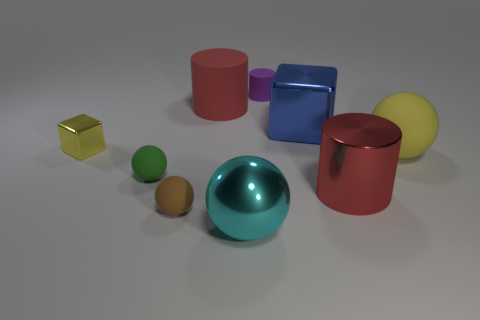Add 1 cyan balls. How many objects exist? 10 Subtract all balls. How many objects are left? 5 Add 5 big gray blocks. How many big gray blocks exist? 5 Subtract 0 yellow cylinders. How many objects are left? 9 Subtract all big cyan rubber blocks. Subtract all small matte balls. How many objects are left? 7 Add 5 red cylinders. How many red cylinders are left? 7 